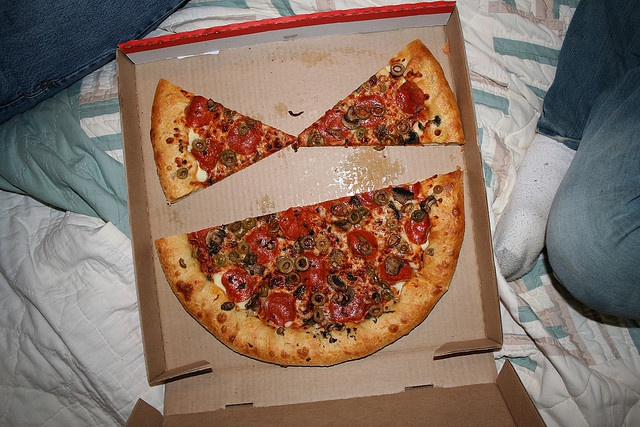Describe the objects in this image and their specific colors. I can see bed in darkgray, black, gray, tan, and brown tones, pizza in black, brown, maroon, and tan tones, people in black, gray, darkgray, and blue tones, pizza in black, brown, maroon, and tan tones, and pizza in black, maroon, brown, and tan tones in this image. 